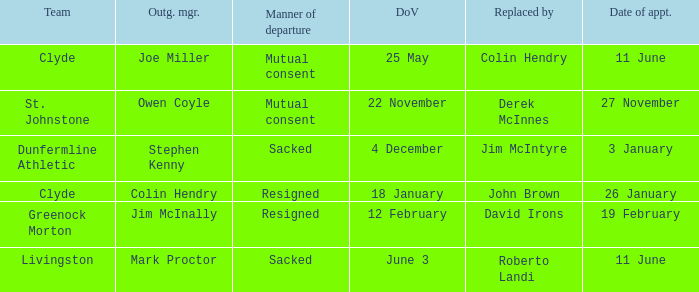Name the manner of departyre for 26 january date of appointment Resigned. 